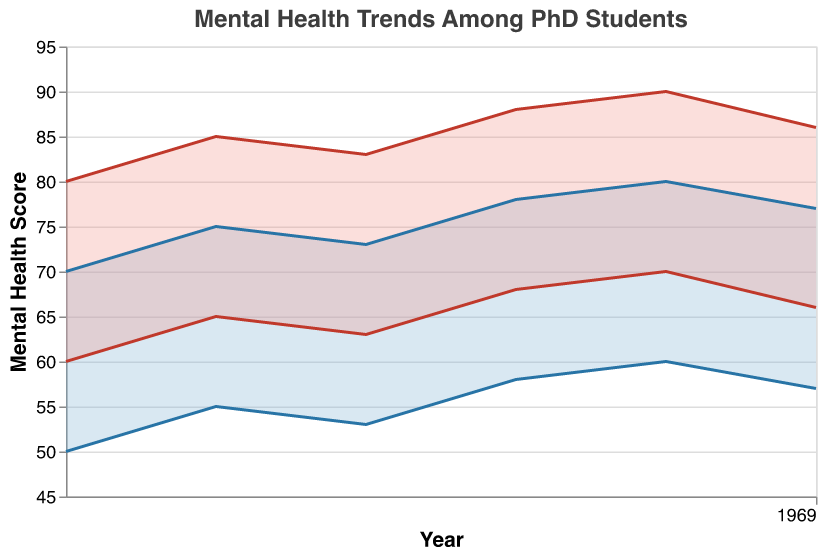What's the title of the chart? The title of the chart is typically found at the top of the figure.
Answer: Mental Health Trends Among PhD Students What are the colors used to represent the First Year and Final Year data? The colors used for First Year and Final Year data can be seen in the shaded areas of the chart. The First Year data is represented in blue (#7FB3D5) while the Final Year data is represented in red (#F1948A).
Answer: Blue and Red How does the upper range of mental health scores for first-year students change from 2017 to 2022? To find this, look at the upper boundary line of the First Year area in the chart from 2017 to 2022. In 2017, the upper range is 70, and in 2022, it drops slightly to 77.
Answer: It increased from 70 to 77 In which year did the lower boundary of the final year mental health scores reach its highest value? Examine the lower boundary line of the Final Year area. Identify the point at which this line reaches its highest position on the y-axis. This occurs in 2021 when the lower boundary is at 70.
Answer: 2021 What is the difference between the upper ranges of final year mental health scores in 2020 and 2021? To find this, locate the final year upper boundary values for 2020 and 2021 on the y-axis. Subtract the 2020 upper range (88) from the 2021 upper range (90).
Answer: 2 Between which consecutive years is the change in the lower boundary of first-year mental health scores the smallest? To find this, look at the changes in the lower boundary line of the first year in the chart for consecutive years. The change is smallest between 2019 and 2020 (53 to 58).
Answer: 2019-2020 How many separate ranges are depicted in the chart? The chart depicts two separate ranges: one for the first year and one for the final year of PhD study.
Answer: 2 How does the range of mental health scores for final year students compare to first-year students in 2022? Compare the upper and lower bounds of the final and first-year ranges in 2022. The first-year range is 57-77, and the final-year range is 66-86. Therefore, both the lower and upper bounds of the final year are higher.
Answer: Both higher 